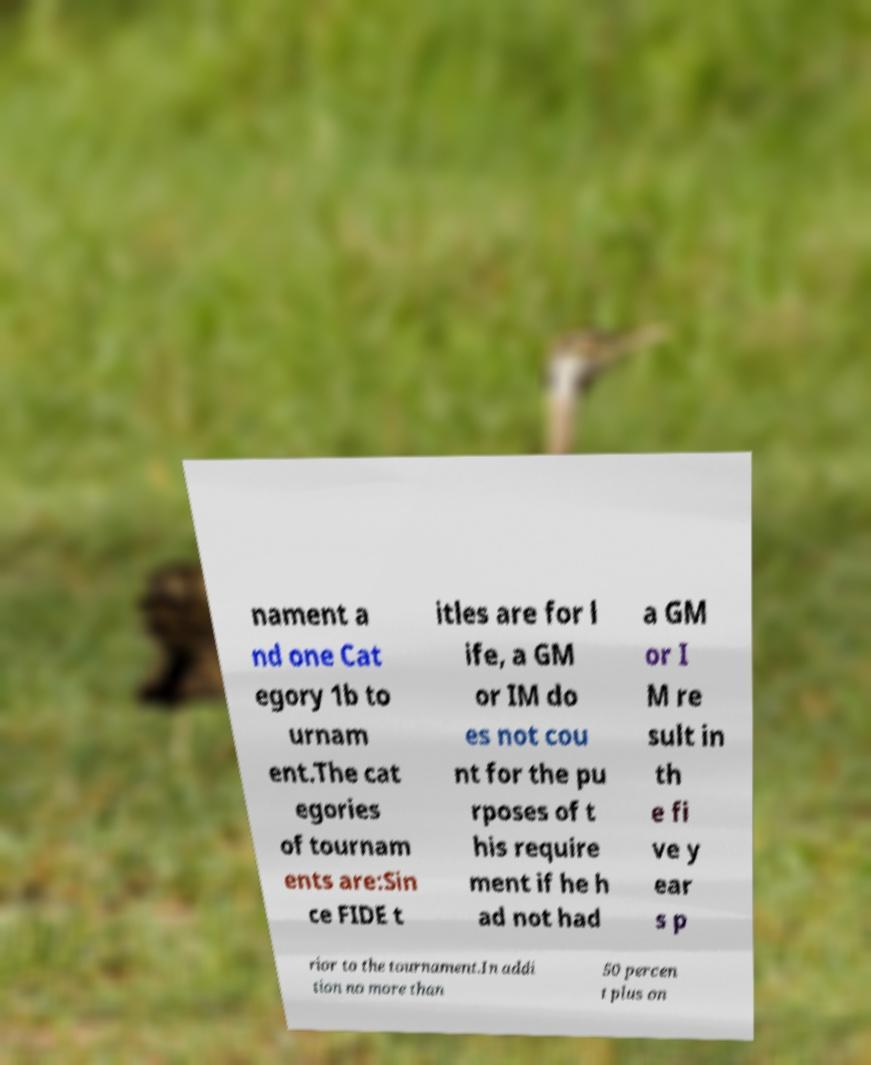Could you assist in decoding the text presented in this image and type it out clearly? nament a nd one Cat egory 1b to urnam ent.The cat egories of tournam ents are:Sin ce FIDE t itles are for l ife, a GM or IM do es not cou nt for the pu rposes of t his require ment if he h ad not had a GM or I M re sult in th e fi ve y ear s p rior to the tournament.In addi tion no more than 50 percen t plus on 